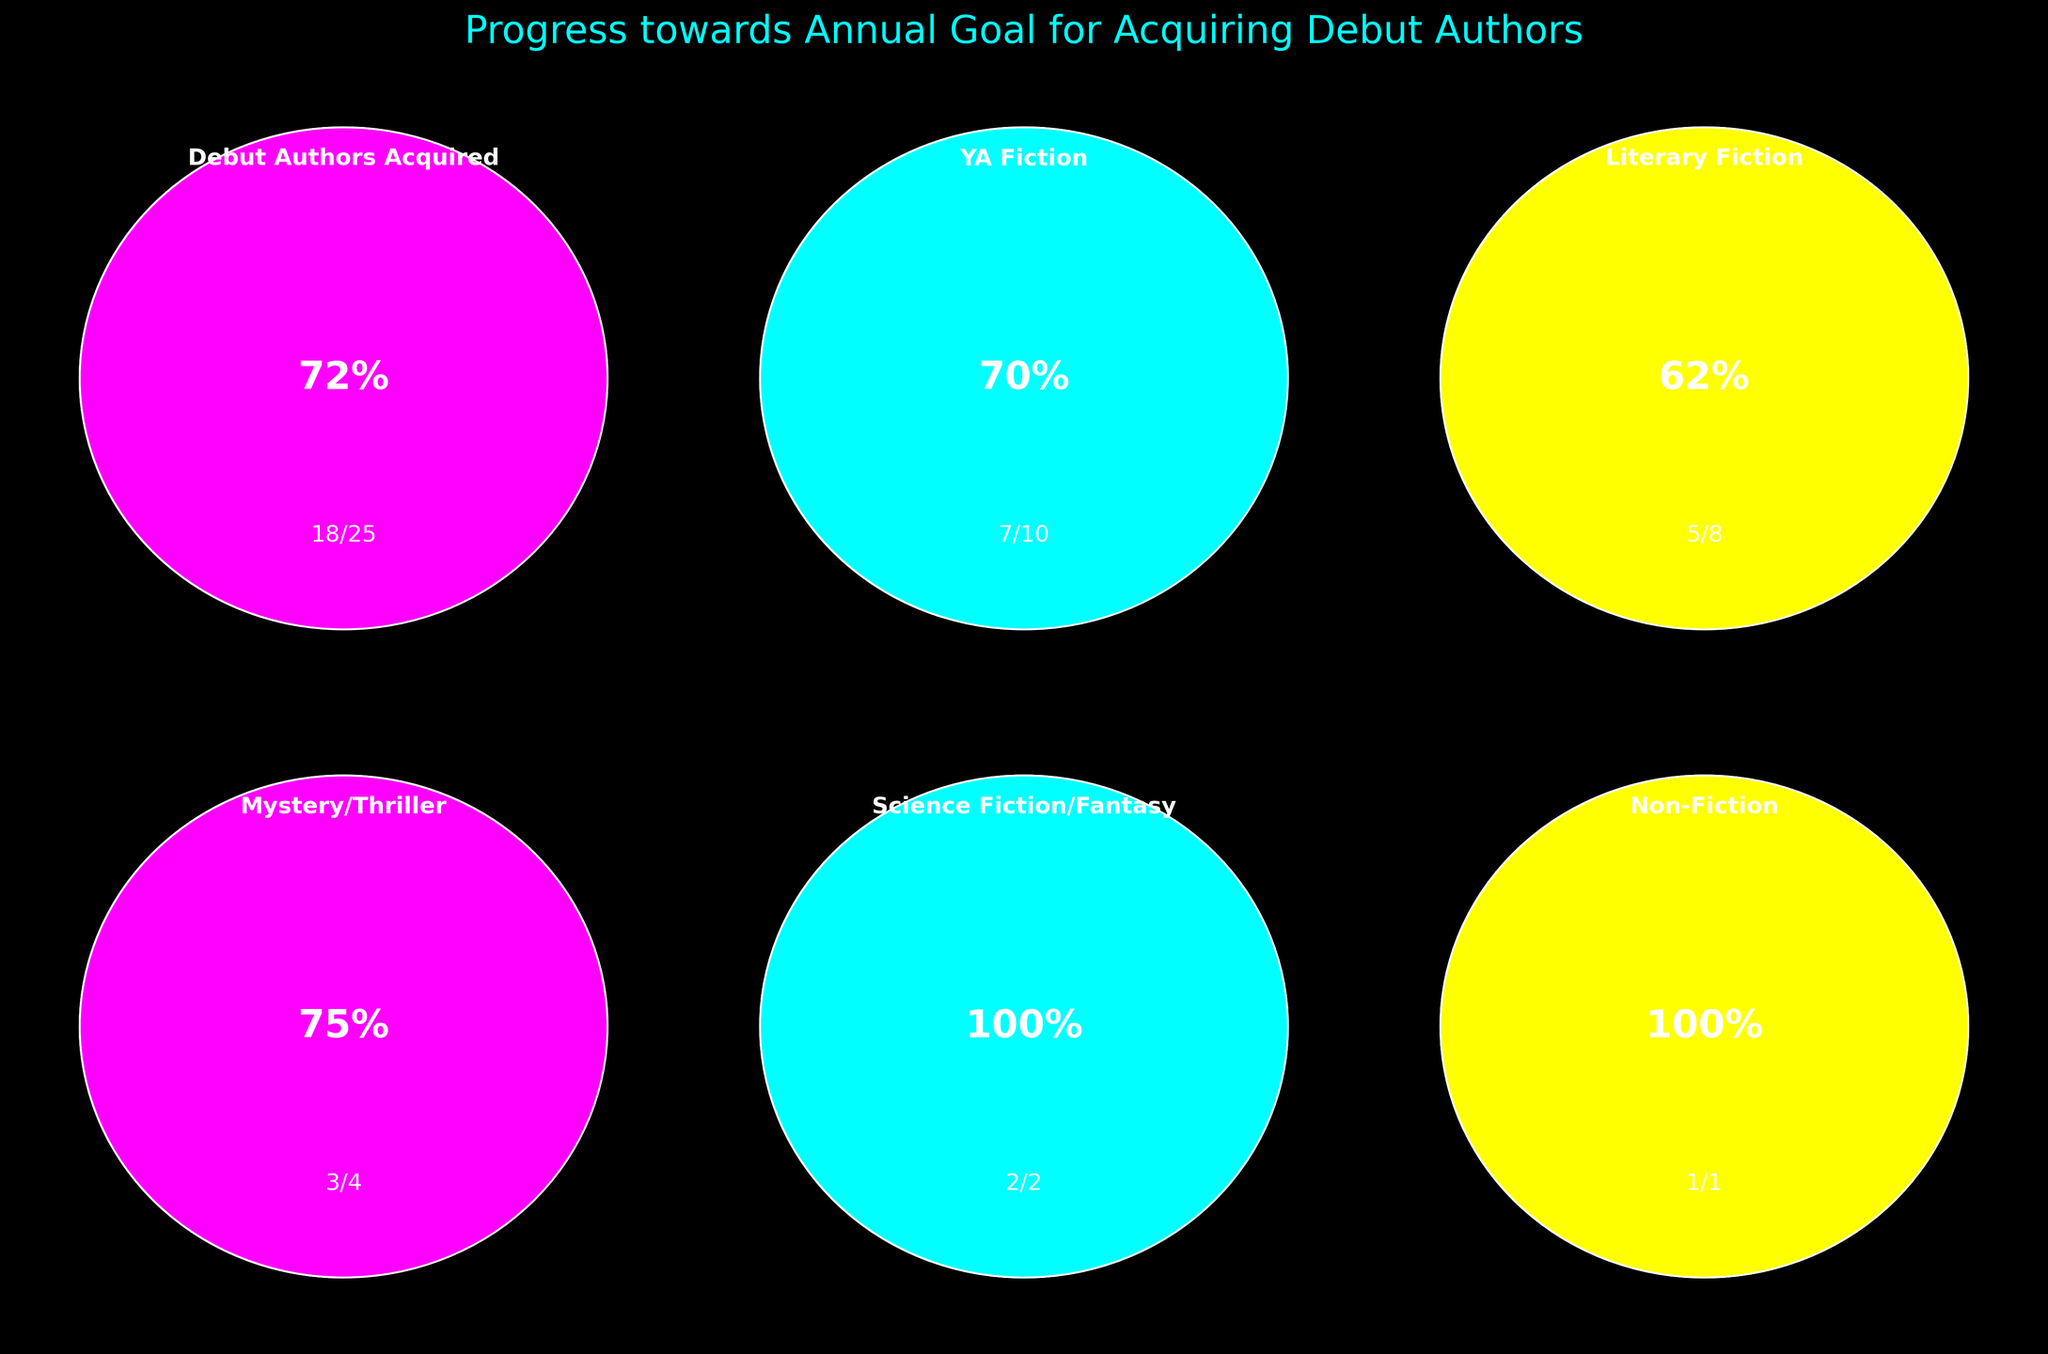How many debut authors have been acquired so far? The title of the gauge is "Debut Authors Acquired," and the figure shows 18 acquired out of 25 targets
Answer: 18 What percentage of the annual goal has been achieved in YA Fiction? The figure for YA Fiction shows a gauge indicating 70% completion, with 7 out of 10 authors acquired
Answer: 70% Which category has the highest completion percentage? Comparing the percentages of all categories (70%, 62.5%, 75%, 100%, and 100%), Mystery/Thriller and Non-Fiction both have 100% completion.
Answer: Mystery/Thriller and Non-Fiction What is the total target number of debut authors across all categories? Summing the target values for all categories: 25 (Debut Authors Acquired) + 10 (YA Fiction) + 8 (Literary Fiction) + 4 (Mystery/Thriller) + 2 (Science Fiction/Fantasy) + 1 (Non-Fiction) = 50
Answer: 50 How does the progress in Literary Fiction compare to that in Science Fiction/Fantasy? Literary Fiction has achieved 62.5% completion (5 out of 8), while Science Fiction/Fantasy has achieved 100% (2 out of 2). Science Fiction/Fantasy is ahead in relative progress.
Answer: Science Fiction/Fantasy is ahead Which two categories have reached their targets? By examining the completion percentages, Science Fiction/Fantasy and Non-Fiction each show 100% completion.
Answer: Science Fiction/Fantasy and Non-Fiction How many more debut authors need to be acquired to meet the overall target? Calculating the remaining authors: 25 - 18 (Debut Authors Acquired) = 7 more authors needed
Answer: 7 What percentage of the overall target has been achieved across all categories? The combined current total is 18 (Debut Authors Acquired) + 7 (YA Fiction) + 5 (Literary Fiction) + 3 (Mystery/Thriller) + 2 (Science Fiction/Fantasy) + 1 (Non-Fiction) = 36 out of 50 target, so (36/50) * 100 = 72%
Answer: 72% Which category requires the acquisition of the most authors to meet its target? Literary Fiction needs 3 more authors to reach its target of 8, which is the highest remaining number among all categories
Answer: Literary Fiction 